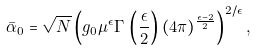Convert formula to latex. <formula><loc_0><loc_0><loc_500><loc_500>\bar { \alpha } _ { 0 } = \sqrt { N } \left ( g _ { 0 } \mu ^ { \epsilon } \Gamma \, \left ( \frac { \epsilon } { 2 } \right ) ( 4 \pi ) ^ { \frac { \epsilon - 2 } { 2 } } \right ) ^ { 2 / \epsilon } ,</formula> 